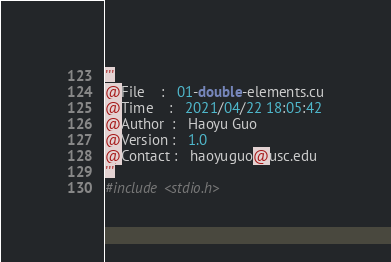Convert code to text. <code><loc_0><loc_0><loc_500><loc_500><_Cuda_>'''
@File    :   01-double-elements.cu
@Time    :   2021/04/22 18:05:42
@Author  :   Haoyu Guo 
@Version :   1.0
@Contact :   haoyuguo@usc.edu
'''
#include <stdio.h>
</code> 